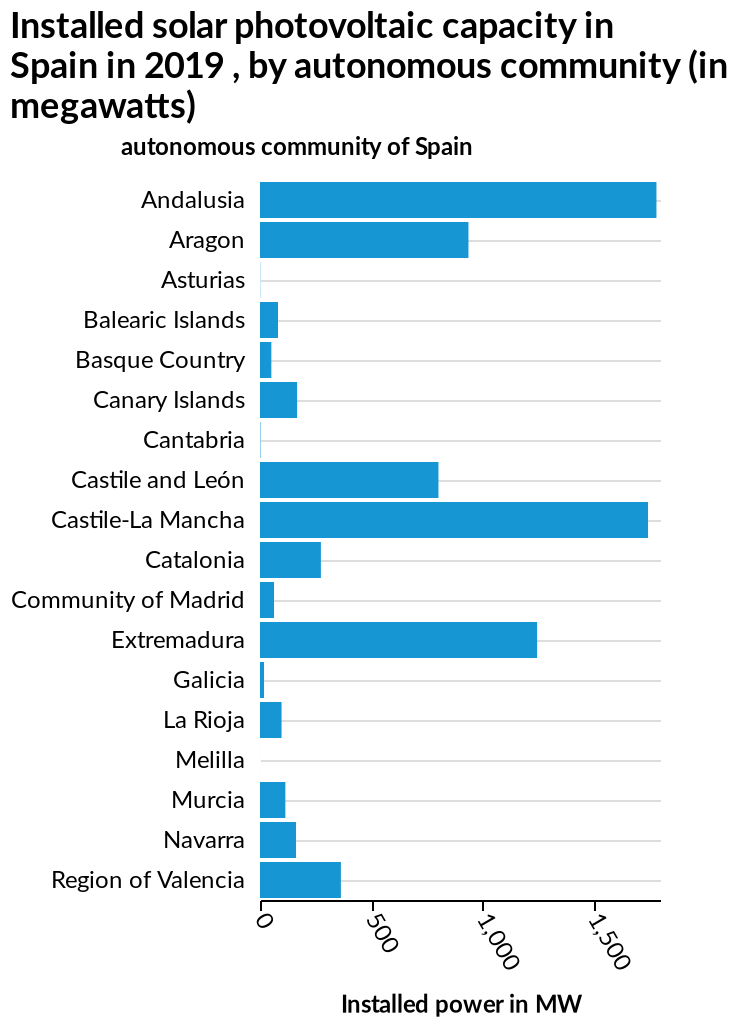<image>
Which autonomous community has the lowest installed solar photovoltaic capacity? The autonomous community with the lowest installed solar photovoltaic capacity is not provided in the description. What is represented on the x-axis of the bar diagram? The x-axis of the bar diagram represents the installed power in megawatts (MW), ranging from 0 to 1,500. Which autonomous community has the highest installed solar photovoltaic capacity? The autonomous community with the highest installed solar photovoltaic capacity is not provided in the description. Which region closely follows Andalucia in terms of installed solar photovoltaic capacity?  Castile La-Mancha closely follows Andalucia in terms of installed solar photovoltaic capacity. 